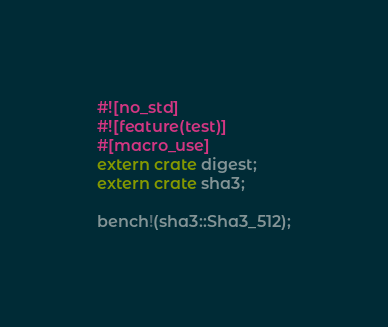Convert code to text. <code><loc_0><loc_0><loc_500><loc_500><_Rust_>#![no_std]
#![feature(test)]
#[macro_use]
extern crate digest;
extern crate sha3;

bench!(sha3::Sha3_512);
</code> 